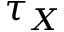<formula> <loc_0><loc_0><loc_500><loc_500>\tau _ { X }</formula> 